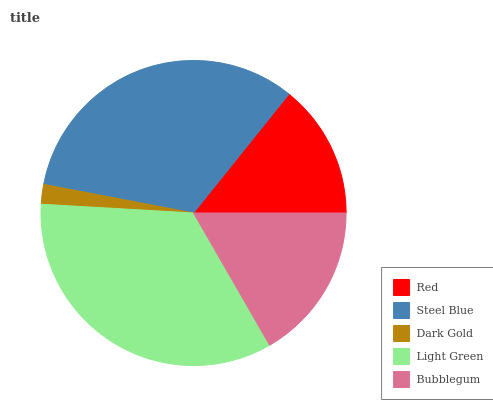Is Dark Gold the minimum?
Answer yes or no. Yes. Is Light Green the maximum?
Answer yes or no. Yes. Is Steel Blue the minimum?
Answer yes or no. No. Is Steel Blue the maximum?
Answer yes or no. No. Is Steel Blue greater than Red?
Answer yes or no. Yes. Is Red less than Steel Blue?
Answer yes or no. Yes. Is Red greater than Steel Blue?
Answer yes or no. No. Is Steel Blue less than Red?
Answer yes or no. No. Is Bubblegum the high median?
Answer yes or no. Yes. Is Bubblegum the low median?
Answer yes or no. Yes. Is Red the high median?
Answer yes or no. No. Is Red the low median?
Answer yes or no. No. 